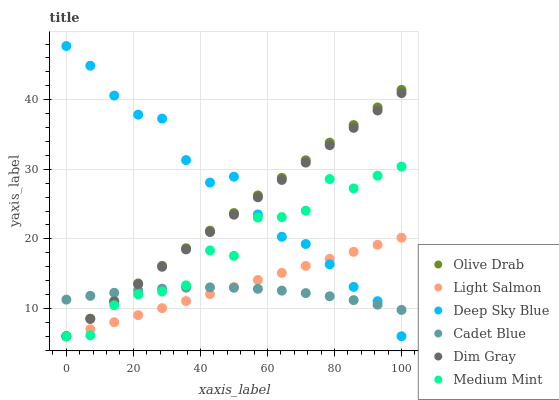Does Cadet Blue have the minimum area under the curve?
Answer yes or no. Yes. Does Deep Sky Blue have the maximum area under the curve?
Answer yes or no. Yes. Does Light Salmon have the minimum area under the curve?
Answer yes or no. No. Does Light Salmon have the maximum area under the curve?
Answer yes or no. No. Is Dim Gray the smoothest?
Answer yes or no. Yes. Is Medium Mint the roughest?
Answer yes or no. Yes. Is Light Salmon the smoothest?
Answer yes or no. No. Is Light Salmon the roughest?
Answer yes or no. No. Does Medium Mint have the lowest value?
Answer yes or no. Yes. Does Cadet Blue have the lowest value?
Answer yes or no. No. Does Deep Sky Blue have the highest value?
Answer yes or no. Yes. Does Light Salmon have the highest value?
Answer yes or no. No. Does Dim Gray intersect Deep Sky Blue?
Answer yes or no. Yes. Is Dim Gray less than Deep Sky Blue?
Answer yes or no. No. Is Dim Gray greater than Deep Sky Blue?
Answer yes or no. No. 